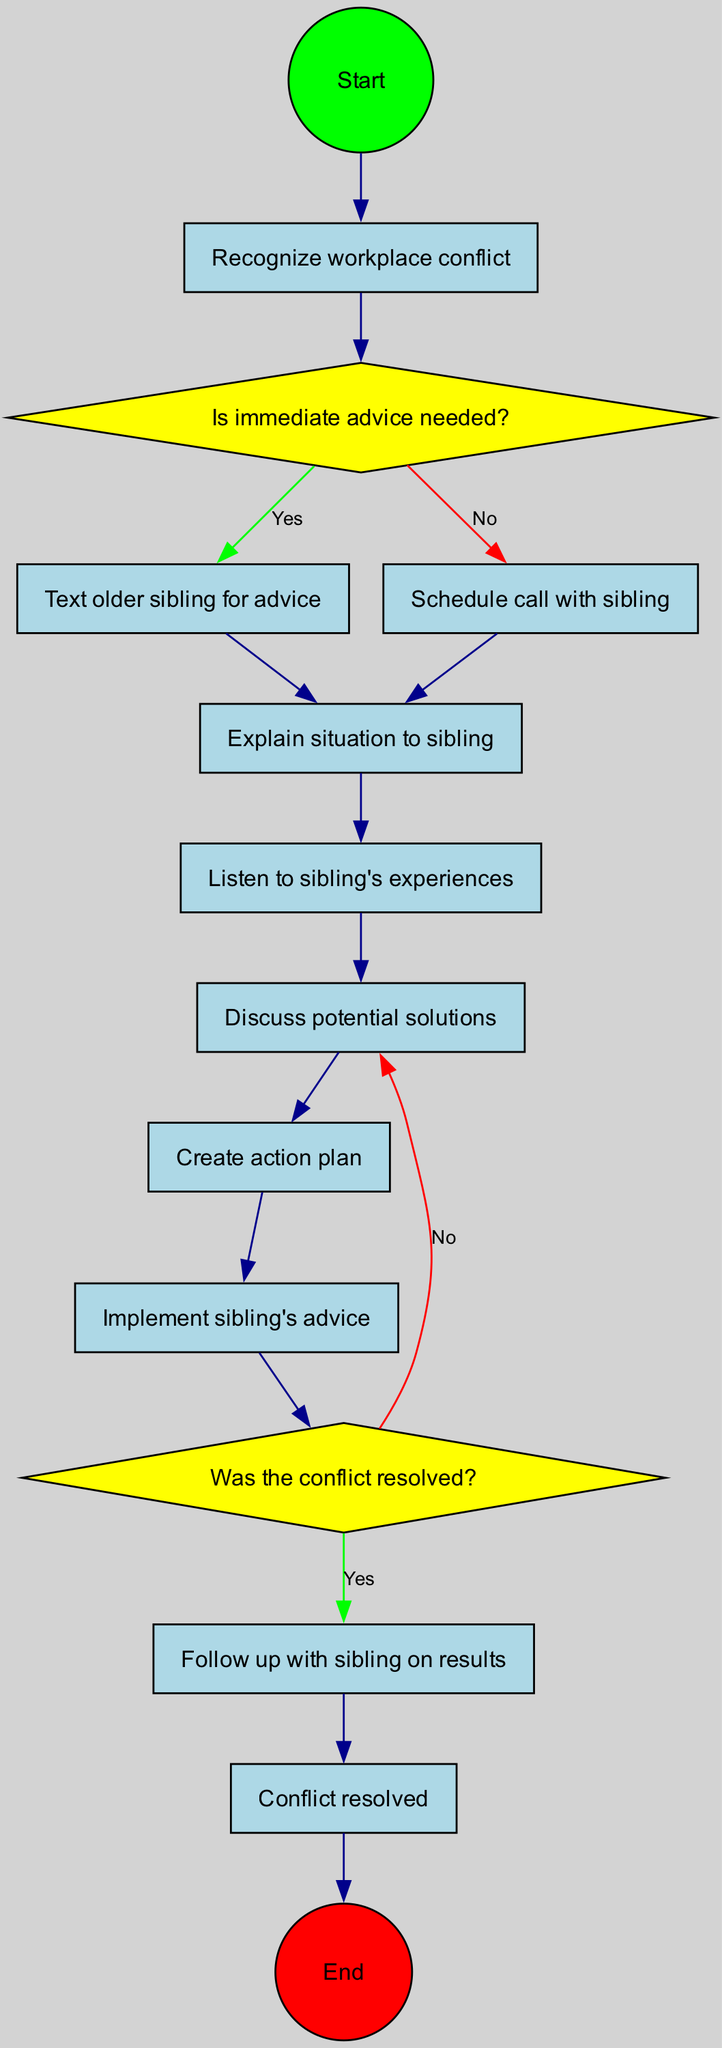What is the initial node of the diagram? The initial node is indicated at the beginning of the diagram flow, showing the starting point which is "Recognize workplace conflict."
Answer: Recognize workplace conflict How many activities are listed in the diagram? By counting the items in the activities section of the diagram, we can determine there are a total of 8 activities outlined.
Answer: 8 What is the first decision question in the diagram? The first decision question is presented right after the initial node, which is "Is immediate advice needed?"
Answer: Is immediate advice needed? What activity follows after "Text older sibling for advice"? Based on the flow of the diagram, the next activity that occurs after "Text older sibling for advice" is "Explain situation to sibling."
Answer: Explain situation to sibling If advice is not needed immediately, which activity comes next? If the answer to the question "Is immediate advice needed?" is no, the flow directs us to "Schedule call with sibling" as the next activity.
Answer: Schedule call with sibling What are the two possible outcomes of the second decision node? The second decision node presents two outcomes based on whether the conflict is resolved or not: "Yes" leading to "Follow up with sibling on results" and "No" leading to "Discuss potential solutions."
Answer: Follow up with sibling on results / Discuss potential solutions How does one transition to implementing advice from the sibling? After discussing potential solutions, the next step in the activity flow is to create an action plan, followed by the implementation of the sibling's advice.
Answer: Create action plan What color represents the decision nodes in the diagram? The decision nodes in the diagram are colored yellow, making them visually distinct from activity nodes.
Answer: Yellow 